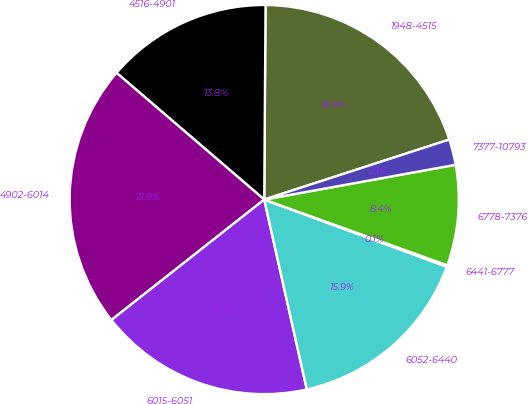<chart> <loc_0><loc_0><loc_500><loc_500><pie_chart><fcel>1948-4515<fcel>4516-4901<fcel>4902-6014<fcel>6015-6051<fcel>6052-6440<fcel>6441-6777<fcel>6778-7376<fcel>7377-10793<nl><fcel>19.9%<fcel>13.82%<fcel>21.91%<fcel>17.89%<fcel>15.88%<fcel>0.12%<fcel>8.35%<fcel>2.13%<nl></chart> 